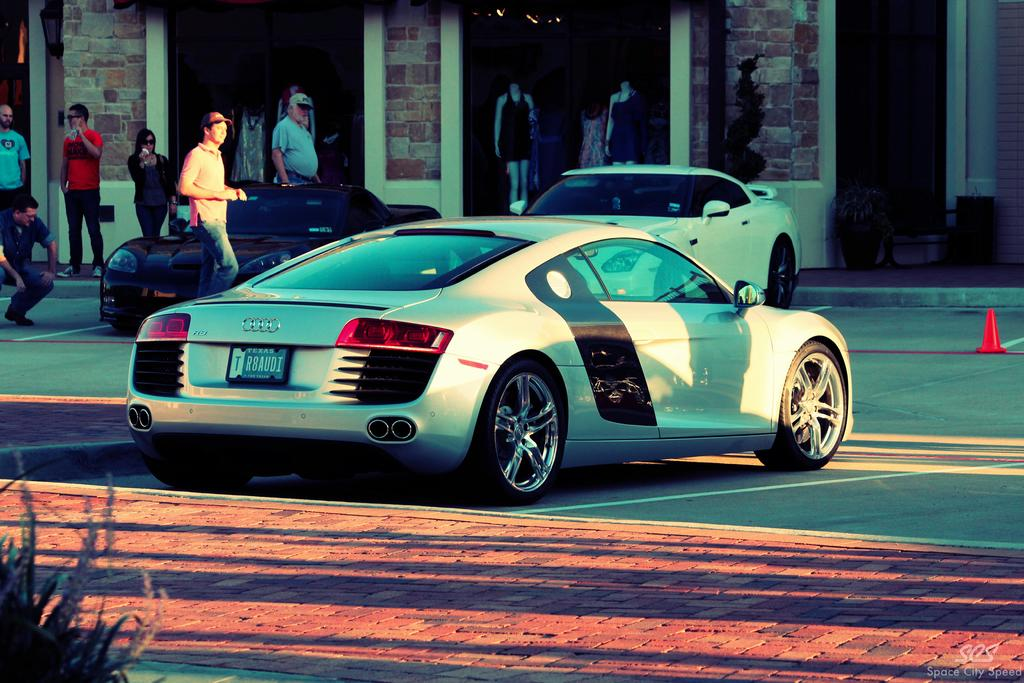What types of objects can be seen in the image? There are vehicles, people, walls, plants, mannequins, and other objects in the image. Can you describe the people in the image? There are people in the image, and two of them are wearing caps. What else is present in the image besides people and objects? There are walls and plants in the image. What are the mannequins doing in the image? The mannequins are stationary and not performing any actions in the image. How many bottles of water are visible in the image? There is no mention of bottles of water in the image; they are not present. What type of pest can be seen crawling on the mannequins in the image? There are no pests visible in the image, and the mannequins are not interacting with any creatures. 